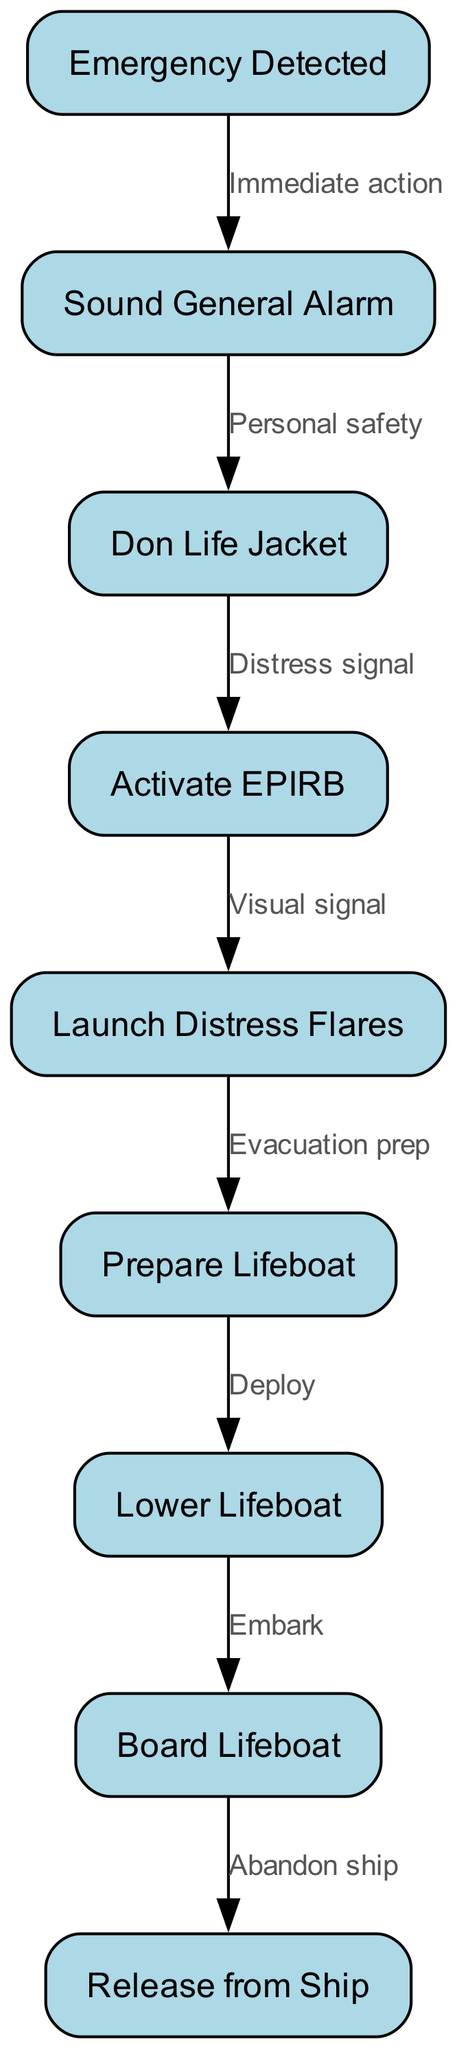What is the first action after an emergency is detected? The flowchart indicates that the first action after detecting an emergency is to "Sound General Alarm." This is directly connected from the "Emergency Detected" node as the next step in the procedure.
Answer: Sound General Alarm How many nodes are present in the diagram? The diagram contains a total of 9 nodes, each representing a specific action or step in the emergency procedures for abandoning ship as listed in the "nodes" section of the data.
Answer: 9 What is the final step in the flowchart? The diagram shows that the final step is "Release from Ship," which is the action to be taken after boarding the lifeboat. It is the last transition in the sequence from the "Board Lifeboat" node.
Answer: Release from Ship What action follows the "Launch Distress Flares"? According to the flowchart, the action that follows "Launch Distress Flares" is "Prepare Lifeboat." This is indicated as the next step connected by an edge between these two nodes.
Answer: Prepare Lifeboat What is the relationship between "Activate EPIRB" and "Don Life Jacket"? The relationship is that "Activate EPIRB" follows "Don Life Jacket," linking personal safety measures with the activation of the Distress signal. The edge between these nodes establishes this sequential order in the emergency procedure.
Answer: Distress signal What action is required before lowering the lifeboat? The diagram specifies that "Prepare Lifeboat" must be completed before the "Lower Lifeboat" action can take place. This sequential decision is shown in the path connecting these two nodes.
Answer: Prepare Lifeboat What is the purpose of sounding the general alarm? The purpose of sounding the general alarm, based on the diagram, is related to ensuring "Personal safety." It is the immediate response after detecting an emergency, indicating that all crew and passengers should become aware of the situation.
Answer: Personal safety Which actions are directly connected to "Board Lifeboat"? The actions directly connected to "Board Lifeboat" include "Lower Lifeboat" (which must happen before boarding) and "Release from Ship" (which happens afterward). The flow shows a sequential relationship starting with lowering the lifeboat.
Answer: Lower Lifeboat, Release from Ship 